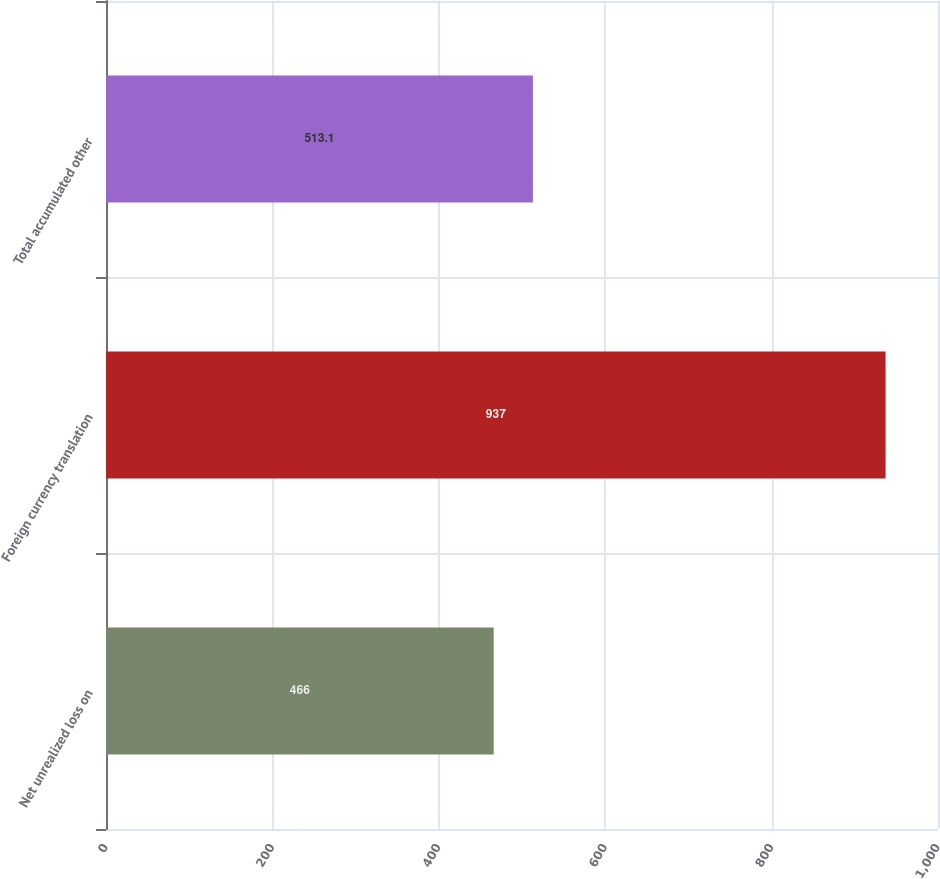Convert chart to OTSL. <chart><loc_0><loc_0><loc_500><loc_500><bar_chart><fcel>Net unrealized loss on<fcel>Foreign currency translation<fcel>Total accumulated other<nl><fcel>466<fcel>937<fcel>513.1<nl></chart> 